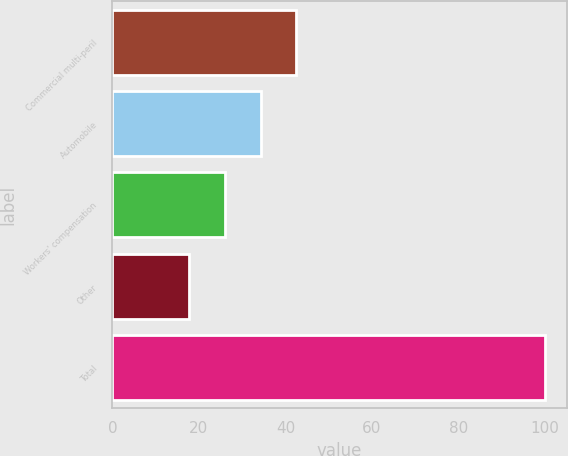<chart> <loc_0><loc_0><loc_500><loc_500><bar_chart><fcel>Commercial multi-peril<fcel>Automobile<fcel>Workers' compensation<fcel>Other<fcel>Total<nl><fcel>42.46<fcel>34.24<fcel>26.02<fcel>17.8<fcel>100<nl></chart> 